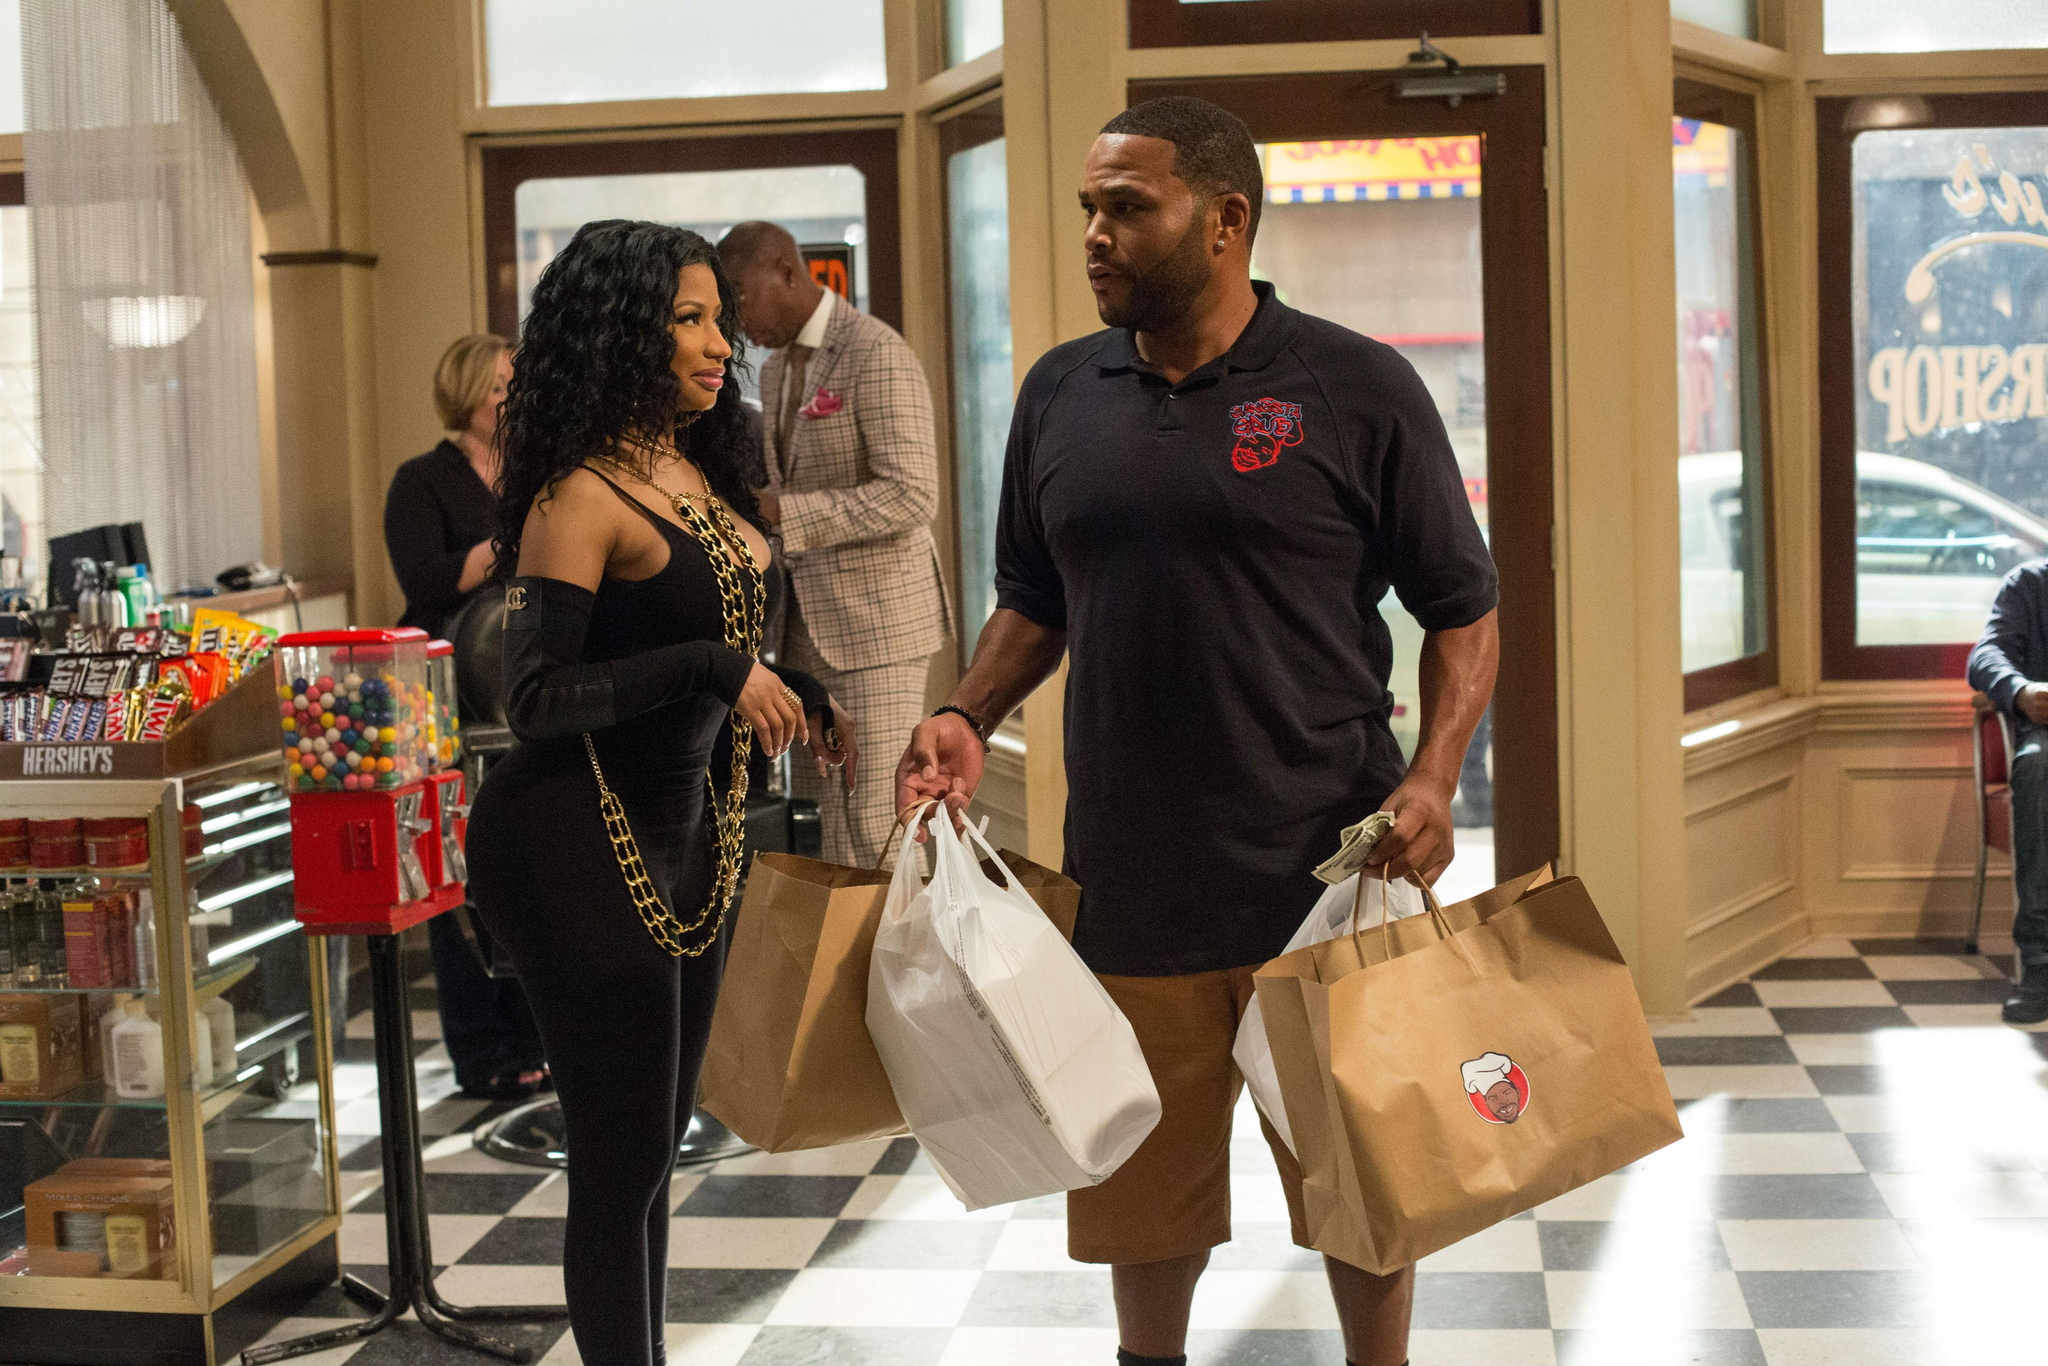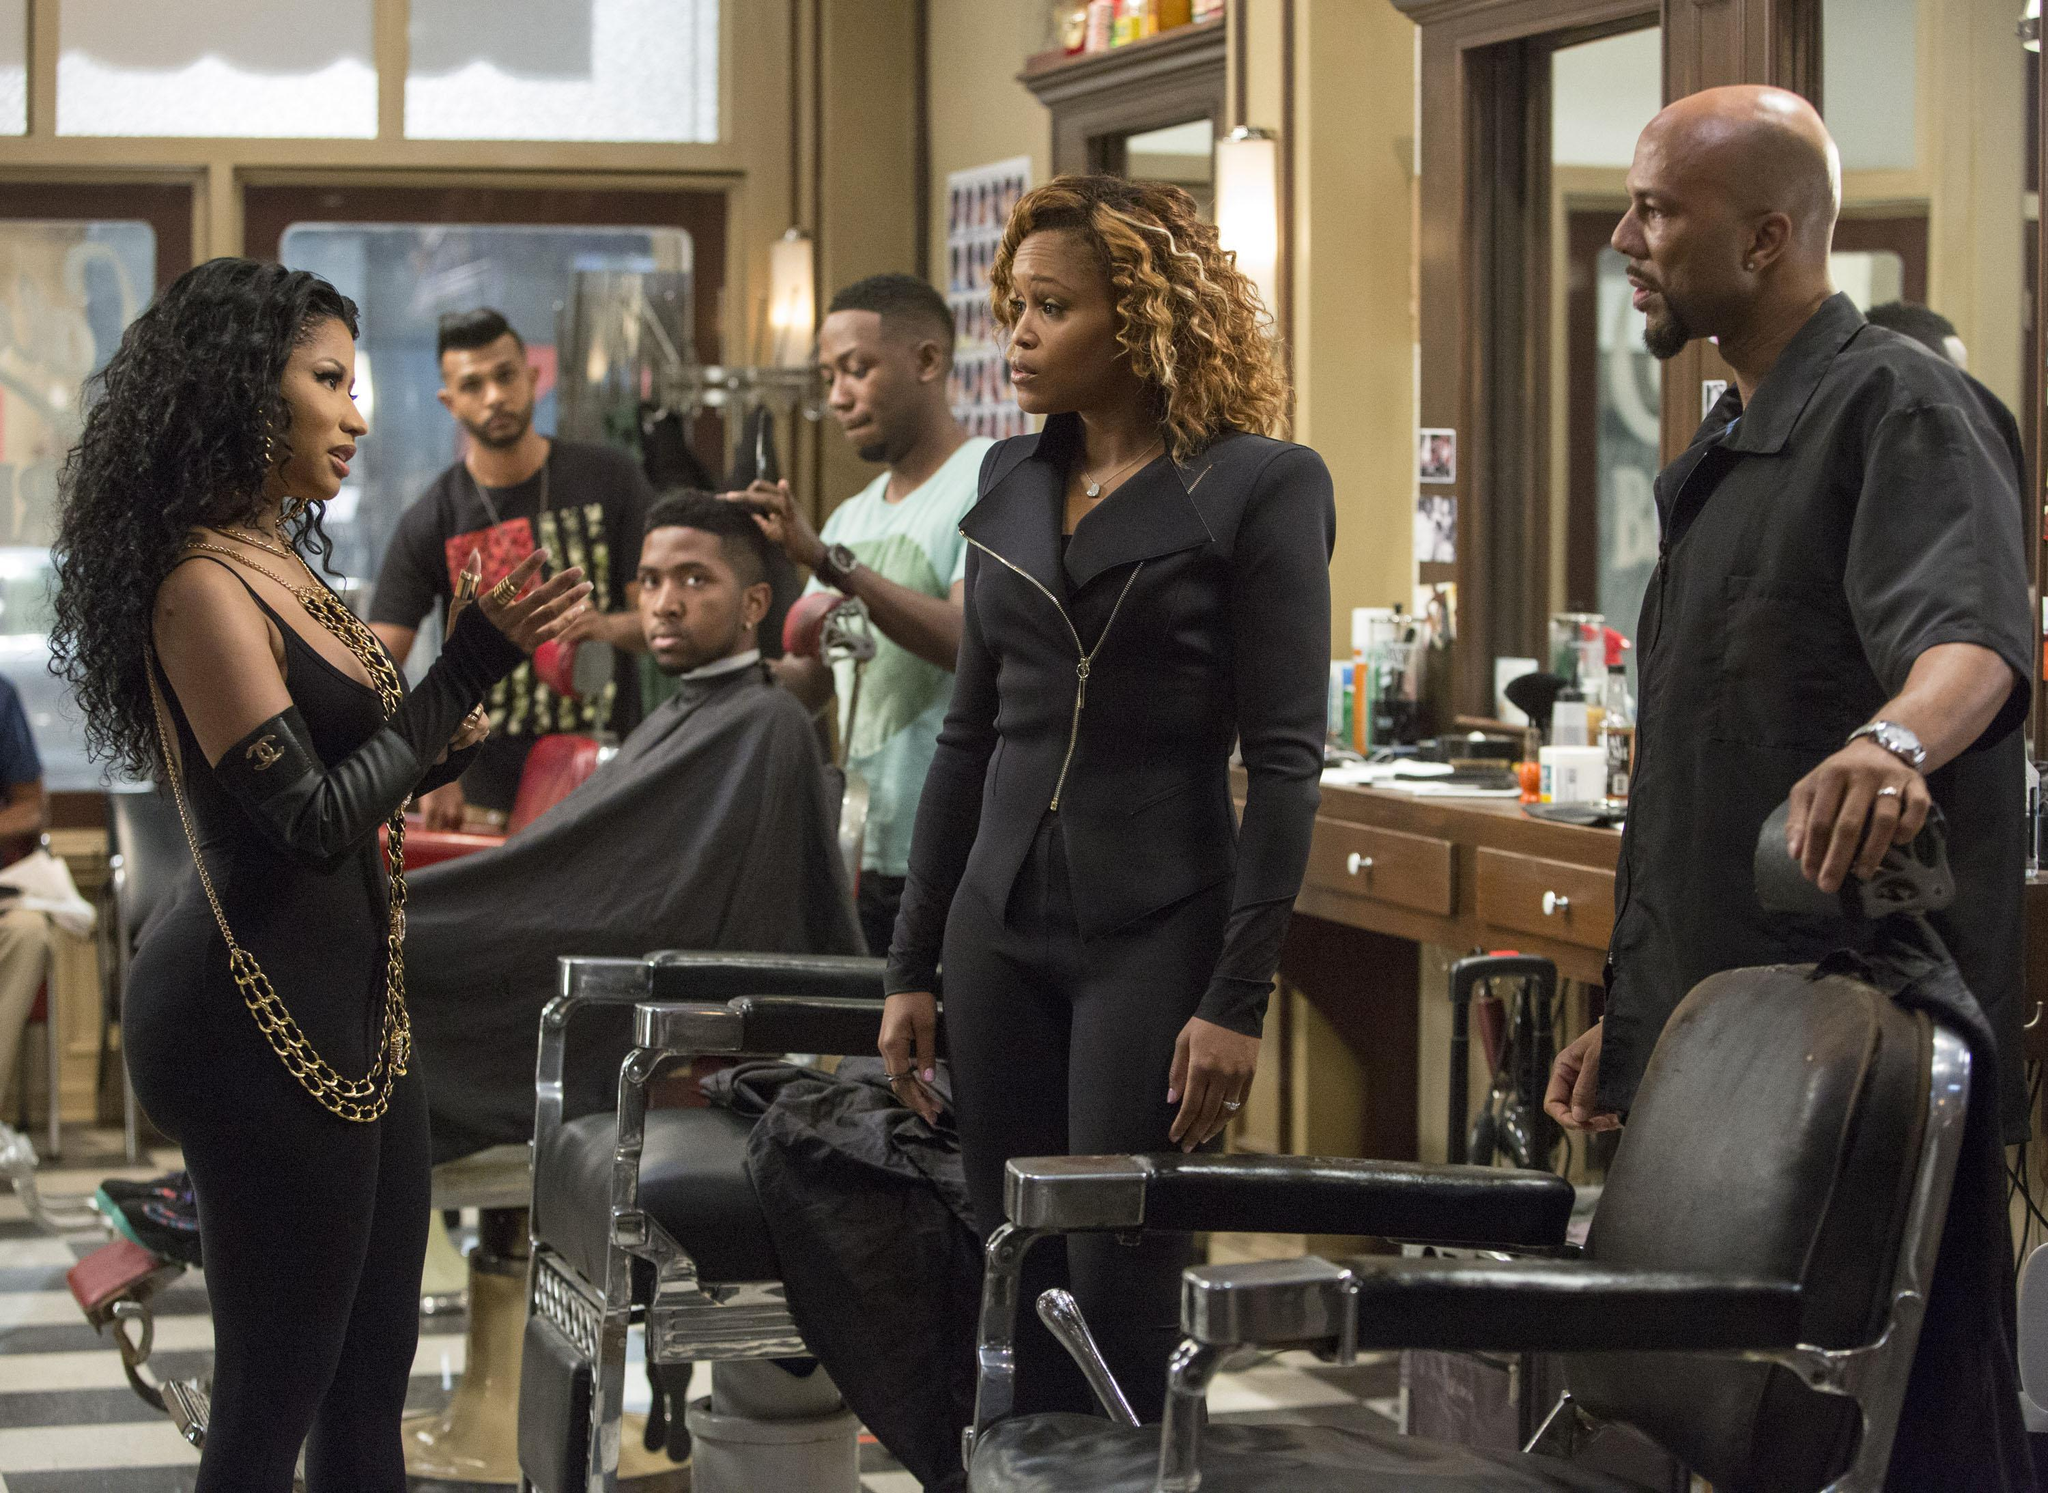The first image is the image on the left, the second image is the image on the right. Evaluate the accuracy of this statement regarding the images: "Only men are present in one of the barbershop images.". Is it true? Answer yes or no. No. The first image is the image on the left, the second image is the image on the right. Given the left and right images, does the statement "There is a woman in red in one of the images." hold true? Answer yes or no. No. 